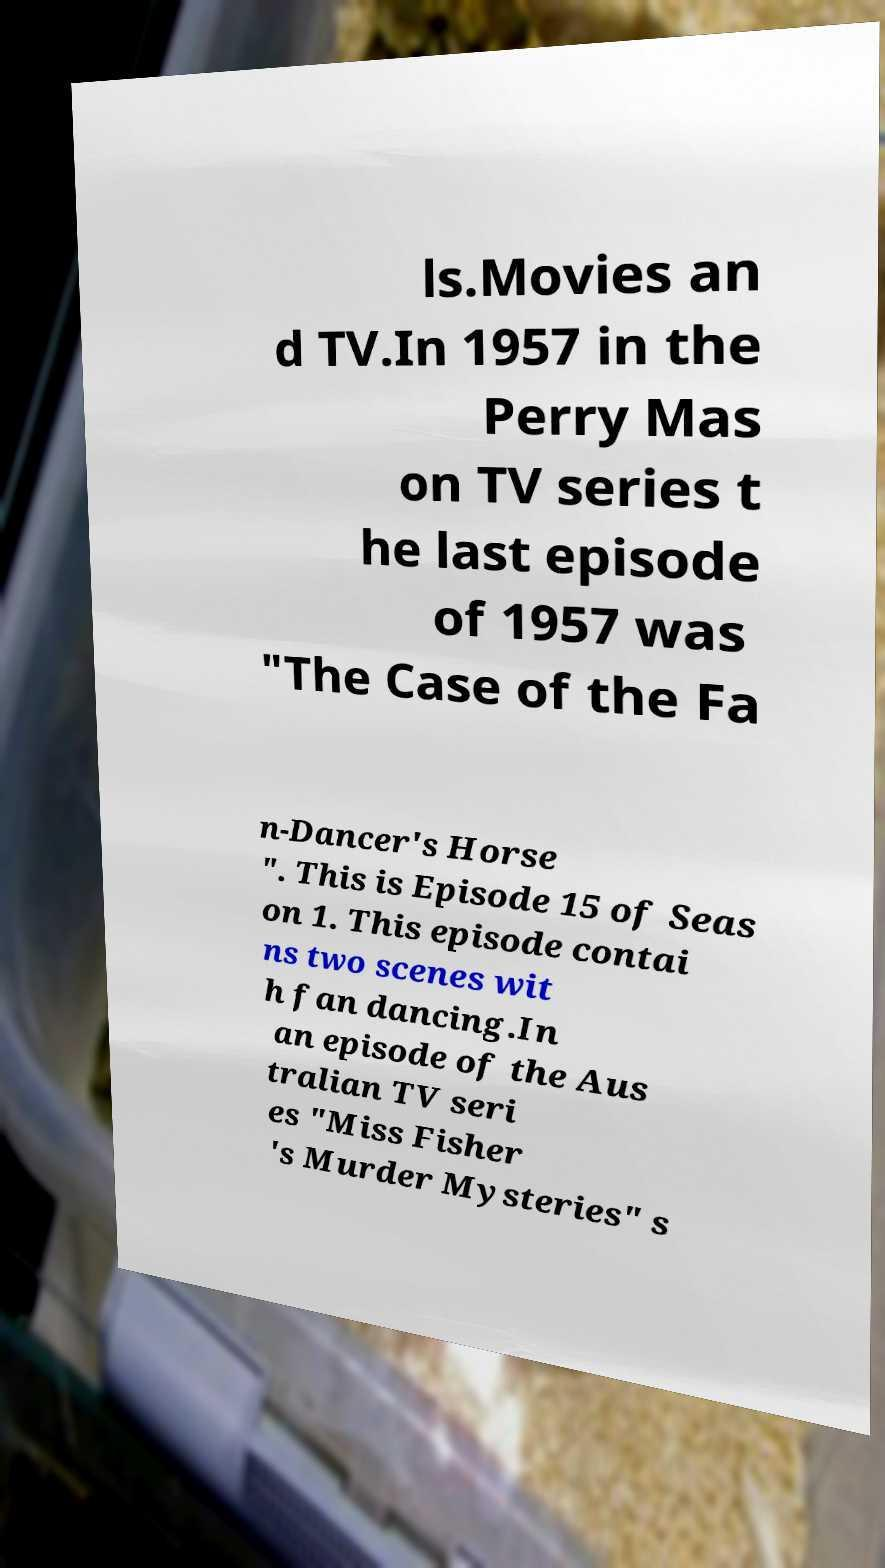Could you extract and type out the text from this image? ls.Movies an d TV.In 1957 in the Perry Mas on TV series t he last episode of 1957 was "The Case of the Fa n-Dancer's Horse ". This is Episode 15 of Seas on 1. This episode contai ns two scenes wit h fan dancing.In an episode of the Aus tralian TV seri es "Miss Fisher 's Murder Mysteries" s 